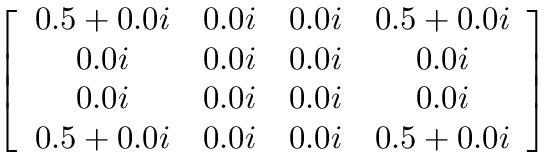<formula> <loc_0><loc_0><loc_500><loc_500>\left [ \begin{array} { c c c c } { 0 . 5 + 0 . 0 i } & { 0 . 0 i } & { 0 . 0 i } & { 0 . 5 + 0 . 0 i } \\ { 0 . 0 i } & { 0 . 0 i } & { 0 . 0 i } & { 0 . 0 i } \\ { 0 . 0 i } & { 0 . 0 i } & { 0 . 0 i } & { 0 . 0 i } \\ { 0 . 5 + 0 . 0 i } & { 0 . 0 i } & { 0 . 0 i } & { 0 . 5 + 0 . 0 i } \end{array} \right ]</formula> 